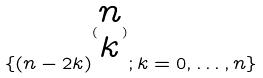<formula> <loc_0><loc_0><loc_500><loc_500>\{ ( n - 2 k ) ^ { ( \begin{matrix} n \\ k \end{matrix} ) } ; k = 0 , \dots , n \}</formula> 